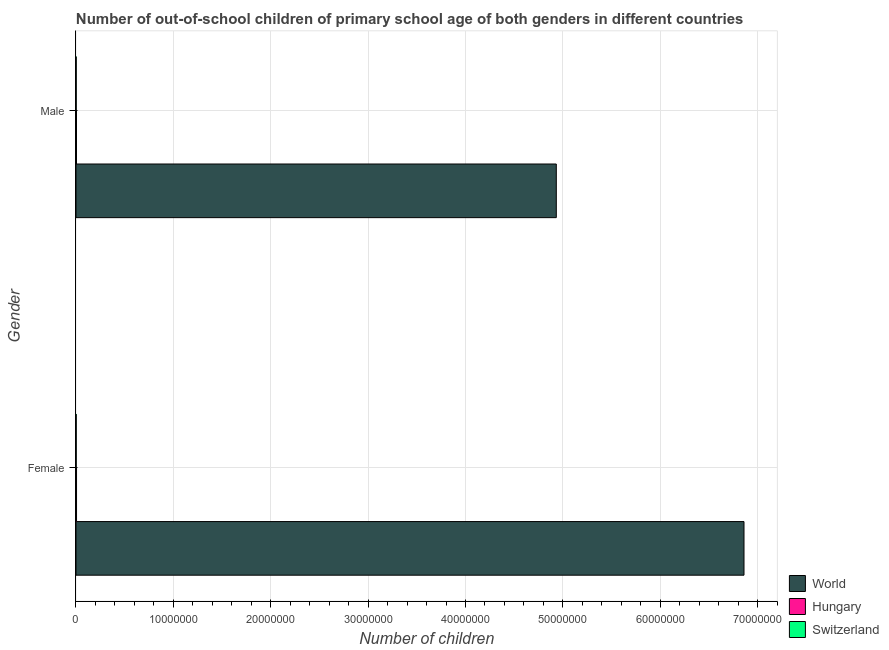How many different coloured bars are there?
Your response must be concise. 3. How many groups of bars are there?
Make the answer very short. 2. What is the number of male out-of-school students in Hungary?
Keep it short and to the point. 5.20e+04. Across all countries, what is the maximum number of male out-of-school students?
Your response must be concise. 4.93e+07. Across all countries, what is the minimum number of male out-of-school students?
Make the answer very short. 2.25e+04. In which country was the number of male out-of-school students minimum?
Offer a very short reply. Switzerland. What is the total number of male out-of-school students in the graph?
Provide a short and direct response. 4.94e+07. What is the difference between the number of female out-of-school students in Switzerland and that in Hungary?
Offer a terse response. -3.31e+04. What is the difference between the number of female out-of-school students in World and the number of male out-of-school students in Hungary?
Provide a succinct answer. 6.86e+07. What is the average number of male out-of-school students per country?
Provide a succinct answer. 1.65e+07. What is the difference between the number of male out-of-school students and number of female out-of-school students in Switzerland?
Your response must be concise. 553. What is the ratio of the number of female out-of-school students in Switzerland to that in Hungary?
Provide a succinct answer. 0.4. In how many countries, is the number of female out-of-school students greater than the average number of female out-of-school students taken over all countries?
Your answer should be very brief. 1. What does the 3rd bar from the bottom in Male represents?
Provide a short and direct response. Switzerland. How many bars are there?
Offer a very short reply. 6. Are all the bars in the graph horizontal?
Ensure brevity in your answer.  Yes. What is the difference between two consecutive major ticks on the X-axis?
Your response must be concise. 1.00e+07. Does the graph contain any zero values?
Provide a short and direct response. No. Does the graph contain grids?
Offer a very short reply. Yes. What is the title of the graph?
Make the answer very short. Number of out-of-school children of primary school age of both genders in different countries. Does "Chile" appear as one of the legend labels in the graph?
Offer a very short reply. No. What is the label or title of the X-axis?
Offer a very short reply. Number of children. What is the Number of children in World in Female?
Keep it short and to the point. 6.86e+07. What is the Number of children in Hungary in Female?
Give a very brief answer. 5.50e+04. What is the Number of children of Switzerland in Female?
Offer a very short reply. 2.19e+04. What is the Number of children of World in Male?
Offer a terse response. 4.93e+07. What is the Number of children of Hungary in Male?
Offer a very short reply. 5.20e+04. What is the Number of children in Switzerland in Male?
Offer a terse response. 2.25e+04. Across all Gender, what is the maximum Number of children of World?
Give a very brief answer. 6.86e+07. Across all Gender, what is the maximum Number of children in Hungary?
Your answer should be compact. 5.50e+04. Across all Gender, what is the maximum Number of children in Switzerland?
Ensure brevity in your answer.  2.25e+04. Across all Gender, what is the minimum Number of children in World?
Your answer should be compact. 4.93e+07. Across all Gender, what is the minimum Number of children of Hungary?
Offer a very short reply. 5.20e+04. Across all Gender, what is the minimum Number of children of Switzerland?
Your answer should be compact. 2.19e+04. What is the total Number of children in World in the graph?
Your response must be concise. 1.18e+08. What is the total Number of children of Hungary in the graph?
Provide a short and direct response. 1.07e+05. What is the total Number of children of Switzerland in the graph?
Your response must be concise. 4.44e+04. What is the difference between the Number of children in World in Female and that in Male?
Provide a succinct answer. 1.93e+07. What is the difference between the Number of children of Hungary in Female and that in Male?
Your answer should be compact. 3043. What is the difference between the Number of children in Switzerland in Female and that in Male?
Make the answer very short. -553. What is the difference between the Number of children of World in Female and the Number of children of Hungary in Male?
Provide a short and direct response. 6.86e+07. What is the difference between the Number of children of World in Female and the Number of children of Switzerland in Male?
Ensure brevity in your answer.  6.86e+07. What is the difference between the Number of children in Hungary in Female and the Number of children in Switzerland in Male?
Provide a succinct answer. 3.26e+04. What is the average Number of children of World per Gender?
Your answer should be very brief. 5.90e+07. What is the average Number of children of Hungary per Gender?
Your answer should be very brief. 5.35e+04. What is the average Number of children in Switzerland per Gender?
Provide a short and direct response. 2.22e+04. What is the difference between the Number of children in World and Number of children in Hungary in Female?
Offer a very short reply. 6.85e+07. What is the difference between the Number of children in World and Number of children in Switzerland in Female?
Your response must be concise. 6.86e+07. What is the difference between the Number of children of Hungary and Number of children of Switzerland in Female?
Keep it short and to the point. 3.31e+04. What is the difference between the Number of children in World and Number of children in Hungary in Male?
Ensure brevity in your answer.  4.93e+07. What is the difference between the Number of children in World and Number of children in Switzerland in Male?
Your answer should be very brief. 4.93e+07. What is the difference between the Number of children in Hungary and Number of children in Switzerland in Male?
Give a very brief answer. 2.95e+04. What is the ratio of the Number of children in World in Female to that in Male?
Offer a very short reply. 1.39. What is the ratio of the Number of children in Hungary in Female to that in Male?
Your answer should be compact. 1.06. What is the ratio of the Number of children in Switzerland in Female to that in Male?
Provide a short and direct response. 0.98. What is the difference between the highest and the second highest Number of children in World?
Your response must be concise. 1.93e+07. What is the difference between the highest and the second highest Number of children of Hungary?
Make the answer very short. 3043. What is the difference between the highest and the second highest Number of children of Switzerland?
Offer a terse response. 553. What is the difference between the highest and the lowest Number of children of World?
Your answer should be compact. 1.93e+07. What is the difference between the highest and the lowest Number of children of Hungary?
Offer a terse response. 3043. What is the difference between the highest and the lowest Number of children in Switzerland?
Keep it short and to the point. 553. 